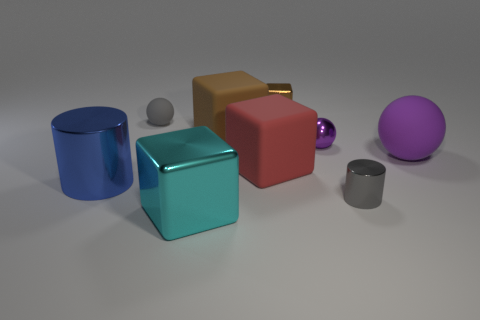Is the number of tiny blocks that are in front of the cyan thing less than the number of cyan shiny objects?
Ensure brevity in your answer.  Yes. There is a gray object that is on the right side of the brown metal thing; does it have the same size as the large blue cylinder?
Keep it short and to the point. No. What number of shiny objects are to the left of the gray matte ball and behind the big brown block?
Offer a very short reply. 0. How big is the metal thing behind the big block behind the small purple metallic thing?
Make the answer very short. Small. Is the number of big red objects on the left side of the brown matte object less than the number of large purple balls that are in front of the red block?
Keep it short and to the point. No. Is the color of the cylinder that is on the right side of the purple metallic sphere the same as the rubber block behind the small metallic ball?
Provide a short and direct response. No. What is the material of the big object that is both in front of the red thing and right of the blue metal thing?
Your response must be concise. Metal. Are there any big purple cylinders?
Make the answer very short. No. The small purple thing that is the same material as the cyan block is what shape?
Keep it short and to the point. Sphere. Do the large red matte object and the gray object behind the blue cylinder have the same shape?
Offer a very short reply. No. 